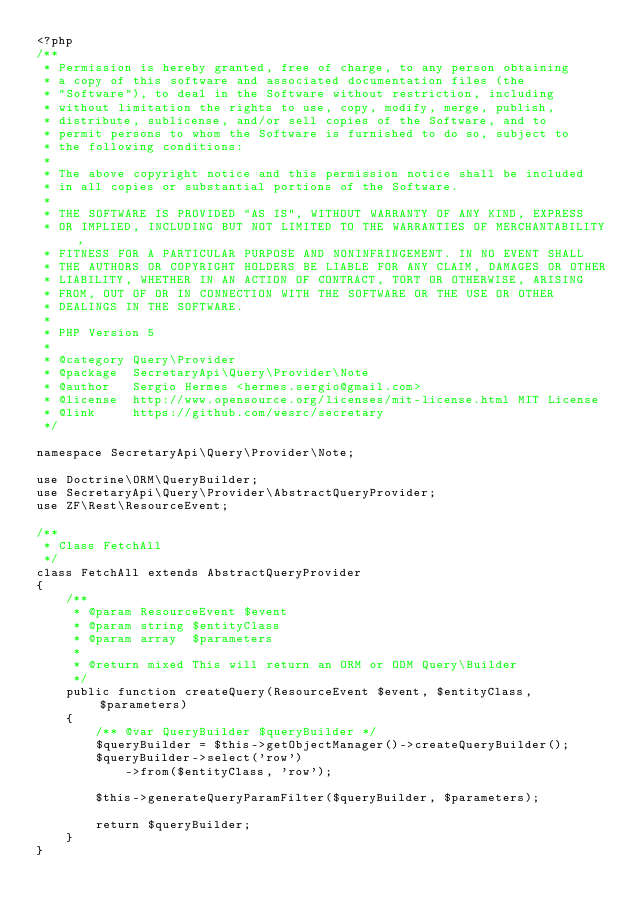<code> <loc_0><loc_0><loc_500><loc_500><_PHP_><?php
/**
 * Permission is hereby granted, free of charge, to any person obtaining
 * a copy of this software and associated documentation files (the
 * "Software"), to deal in the Software without restriction, including
 * without limitation the rights to use, copy, modify, merge, publish,
 * distribute, sublicense, and/or sell copies of the Software, and to
 * permit persons to whom the Software is furnished to do so, subject to
 * the following conditions:
 *
 * The above copyright notice and this permission notice shall be included
 * in all copies or substantial portions of the Software.
 *
 * THE SOFTWARE IS PROVIDED "AS IS", WITHOUT WARRANTY OF ANY KIND, EXPRESS
 * OR IMPLIED, INCLUDING BUT NOT LIMITED TO THE WARRANTIES OF MERCHANTABILITY,
 * FITNESS FOR A PARTICULAR PURPOSE AND NONINFRINGEMENT. IN NO EVENT SHALL
 * THE AUTHORS OR COPYRIGHT HOLDERS BE LIABLE FOR ANY CLAIM, DAMAGES OR OTHER
 * LIABILITY, WHETHER IN AN ACTION OF CONTRACT, TORT OR OTHERWISE, ARISING
 * FROM, OUT OF OR IN CONNECTION WITH THE SOFTWARE OR THE USE OR OTHER
 * DEALINGS IN THE SOFTWARE.
 *
 * PHP Version 5
 *
 * @category Query\Provider
 * @package  SecretaryApi\Query\Provider\Note
 * @author   Sergio Hermes <hermes.sergio@gmail.com>
 * @license  http://www.opensource.org/licenses/mit-license.html MIT License
 * @link     https://github.com/wesrc/secretary
 */

namespace SecretaryApi\Query\Provider\Note;

use Doctrine\ORM\QueryBuilder;
use SecretaryApi\Query\Provider\AbstractQueryProvider;
use ZF\Rest\ResourceEvent;

/**
 * Class FetchAll
 */
class FetchAll extends AbstractQueryProvider
{
    /**
     * @param ResourceEvent $event
     * @param string $entityClass
     * @param array  $parameters
     *
     * @return mixed This will return an ORM or ODM Query\Builder
     */
    public function createQuery(ResourceEvent $event, $entityClass, $parameters)
    {
        /** @var QueryBuilder $queryBuilder */
        $queryBuilder = $this->getObjectManager()->createQueryBuilder();
        $queryBuilder->select('row')
            ->from($entityClass, 'row');

        $this->generateQueryParamFilter($queryBuilder, $parameters);

        return $queryBuilder;
    }
} </code> 